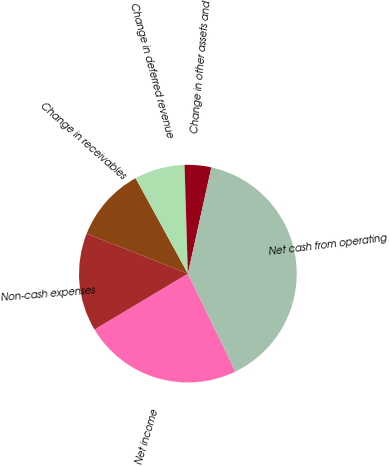<chart> <loc_0><loc_0><loc_500><loc_500><pie_chart><fcel>Net income<fcel>Non-cash expenses<fcel>Change in receivables<fcel>Change in deferred revenue<fcel>Change in other assets and<fcel>Net cash from operating<nl><fcel>23.63%<fcel>14.57%<fcel>11.03%<fcel>7.49%<fcel>3.95%<fcel>39.34%<nl></chart> 